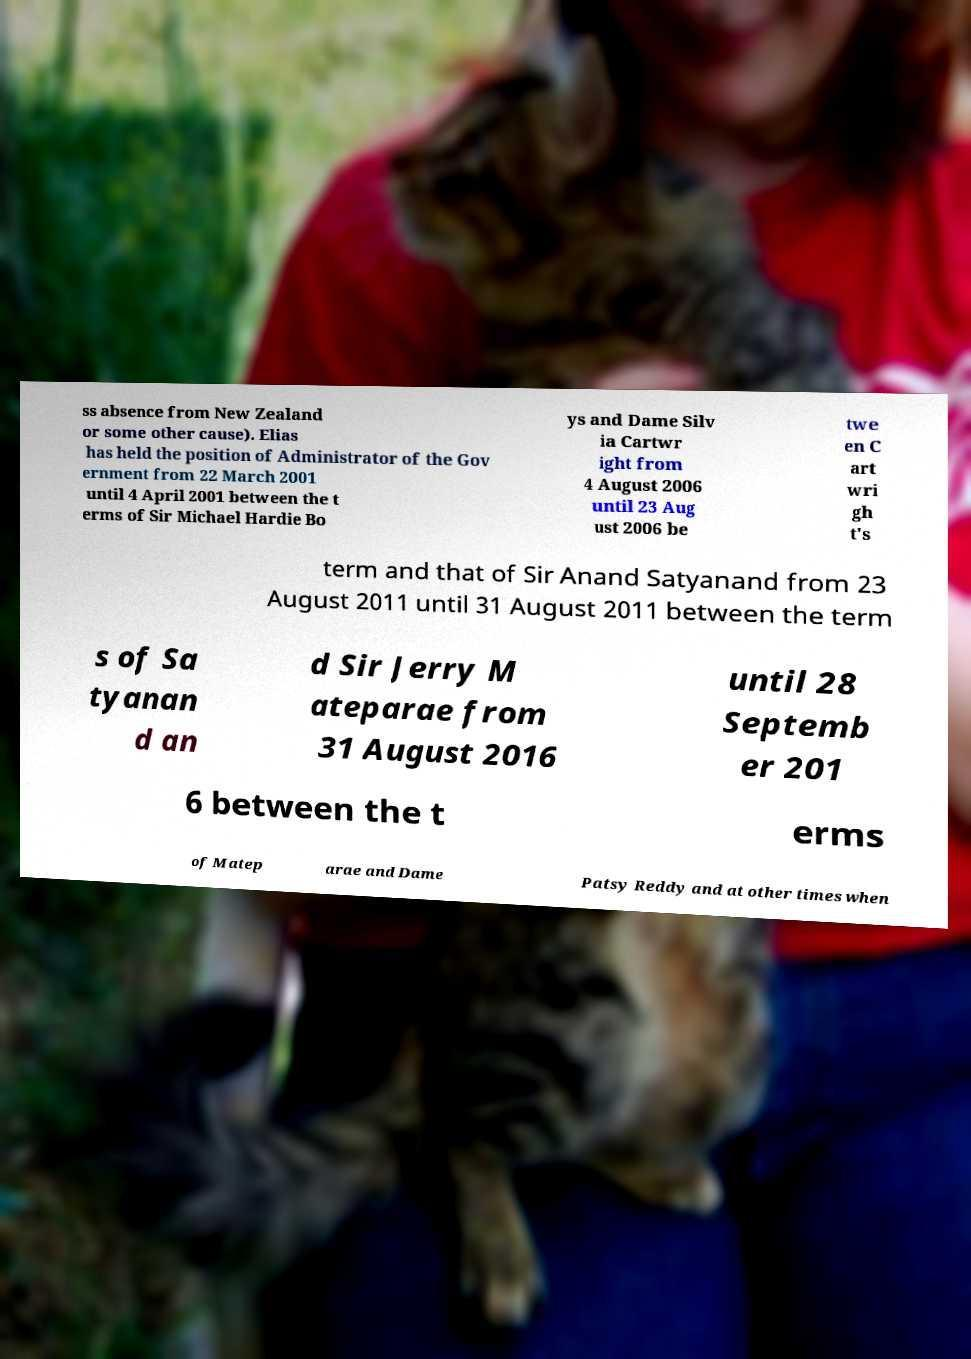For documentation purposes, I need the text within this image transcribed. Could you provide that? ss absence from New Zealand or some other cause). Elias has held the position of Administrator of the Gov ernment from 22 March 2001 until 4 April 2001 between the t erms of Sir Michael Hardie Bo ys and Dame Silv ia Cartwr ight from 4 August 2006 until 23 Aug ust 2006 be twe en C art wri gh t's term and that of Sir Anand Satyanand from 23 August 2011 until 31 August 2011 between the term s of Sa tyanan d an d Sir Jerry M ateparae from 31 August 2016 until 28 Septemb er 201 6 between the t erms of Matep arae and Dame Patsy Reddy and at other times when 